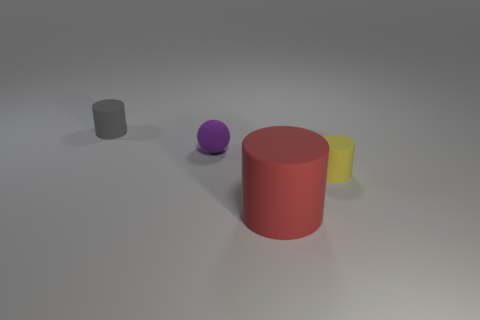What number of other objects are there of the same shape as the small purple matte thing?
Ensure brevity in your answer.  0. What number of objects are either small things that are left of the red matte object or small cylinders that are right of the gray rubber thing?
Your response must be concise. 3. How big is the cylinder that is both to the right of the gray thing and to the left of the yellow cylinder?
Make the answer very short. Large. Does the small rubber thing right of the red matte cylinder have the same shape as the purple matte object?
Provide a short and direct response. No. There is a rubber cylinder that is in front of the small object in front of the purple matte sphere behind the large red rubber thing; what size is it?
Your answer should be compact. Large. How many objects are either tiny shiny cylinders or tiny gray rubber cylinders?
Your answer should be very brief. 1. There is a thing that is both in front of the small sphere and behind the large red rubber cylinder; what shape is it?
Provide a succinct answer. Cylinder. There is a large red thing; is it the same shape as the small purple rubber object behind the yellow thing?
Keep it short and to the point. No. Are there any rubber things right of the small yellow thing?
Your response must be concise. No. What number of cylinders are purple things or red rubber things?
Your answer should be compact. 1. 